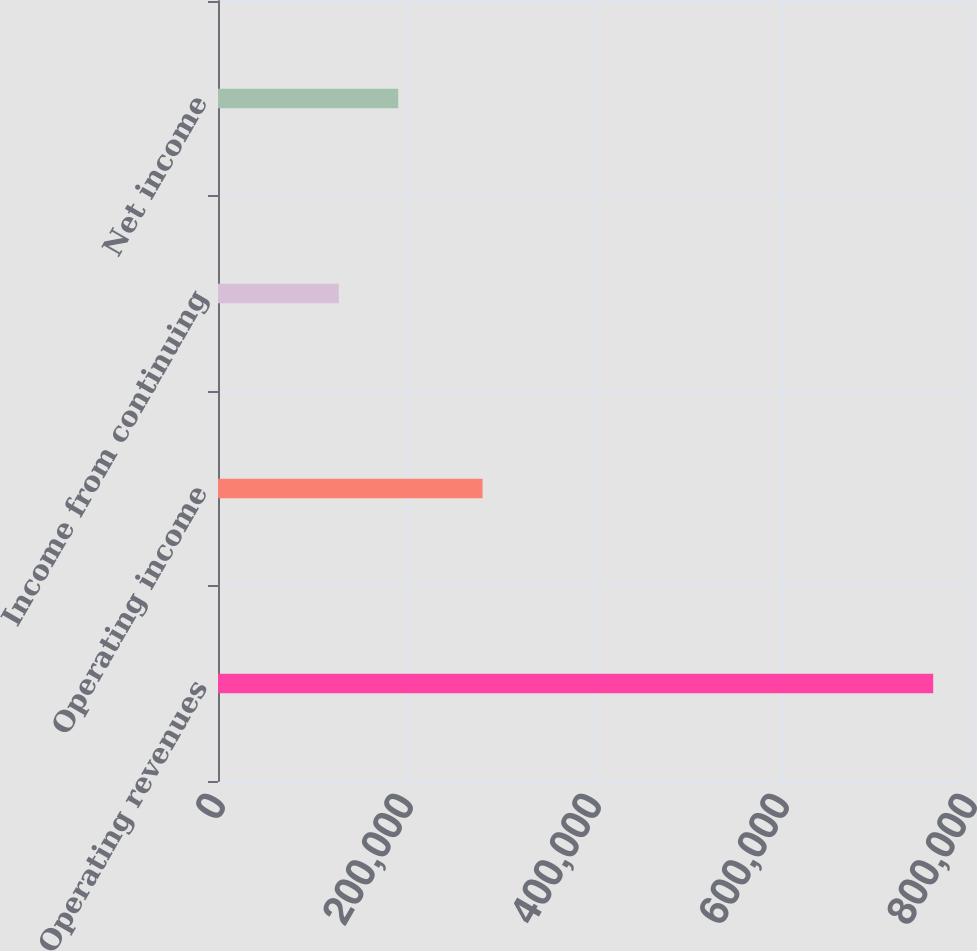Convert chart to OTSL. <chart><loc_0><loc_0><loc_500><loc_500><bar_chart><fcel>Operating revenues<fcel>Operating income<fcel>Income from continuing<fcel>Net income<nl><fcel>760869<fcel>281408<fcel>128495<fcel>191732<nl></chart> 